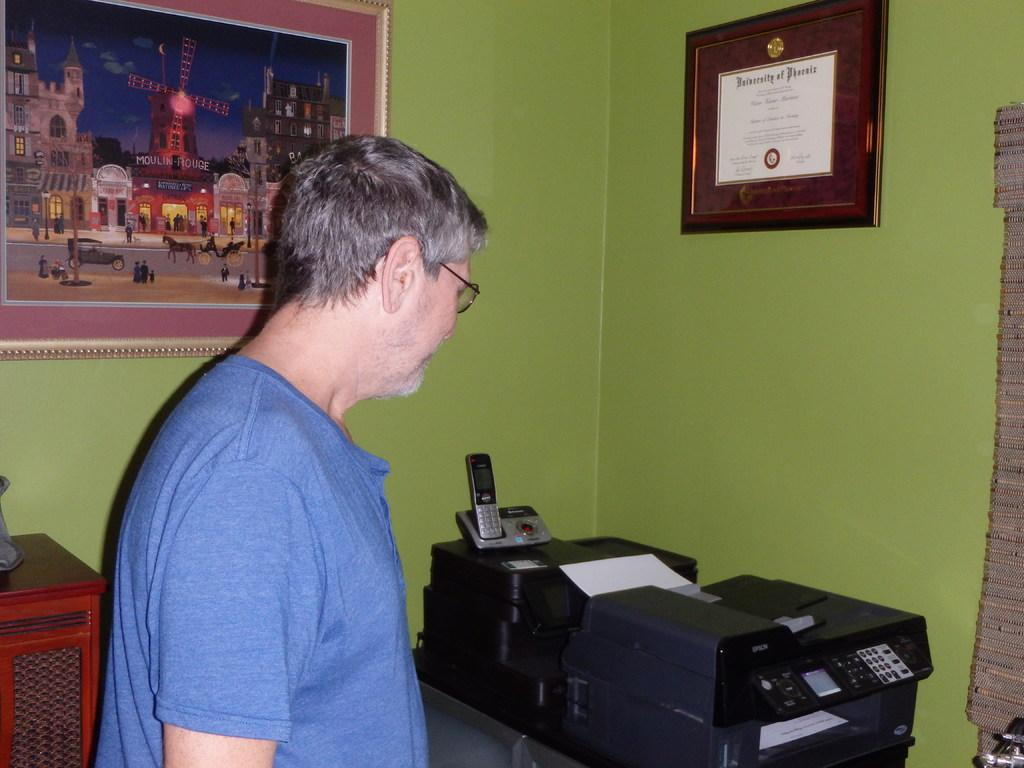<image>
Share a concise interpretation of the image provided. A man looks at a copy machine that's under a University of Phoenix degree on the wall. 